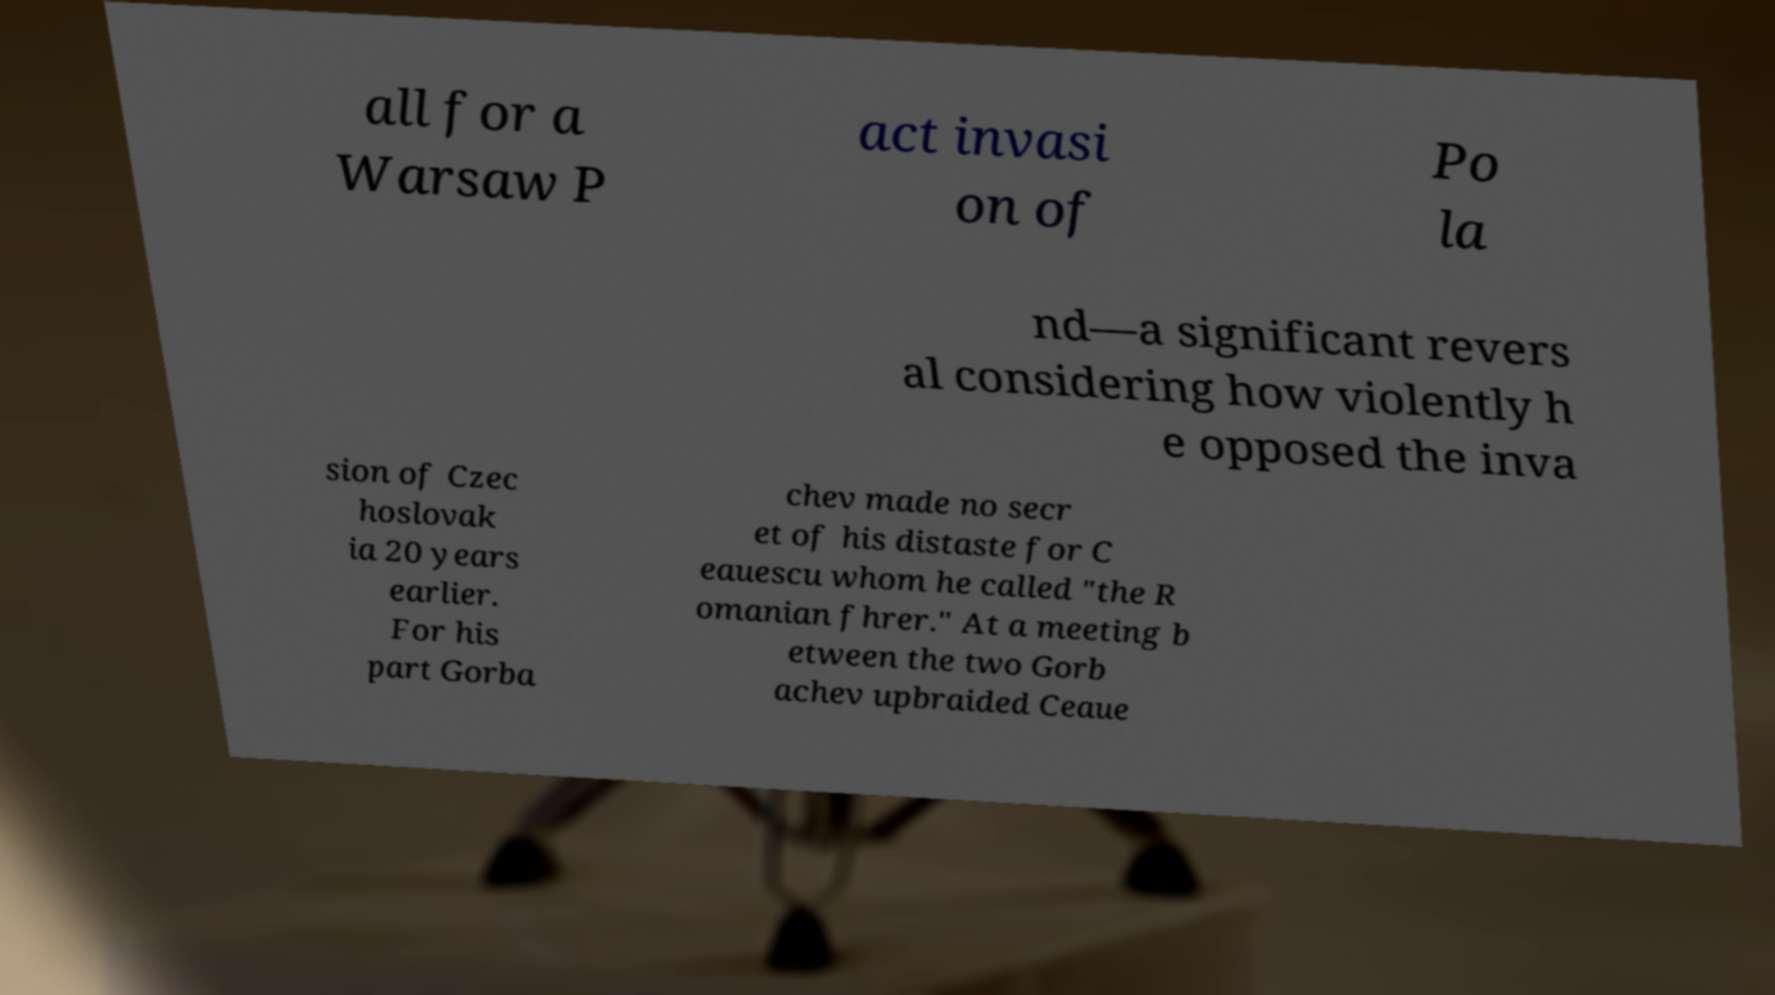What messages or text are displayed in this image? I need them in a readable, typed format. all for a Warsaw P act invasi on of Po la nd—a significant revers al considering how violently h e opposed the inva sion of Czec hoslovak ia 20 years earlier. For his part Gorba chev made no secr et of his distaste for C eauescu whom he called "the R omanian fhrer." At a meeting b etween the two Gorb achev upbraided Ceaue 